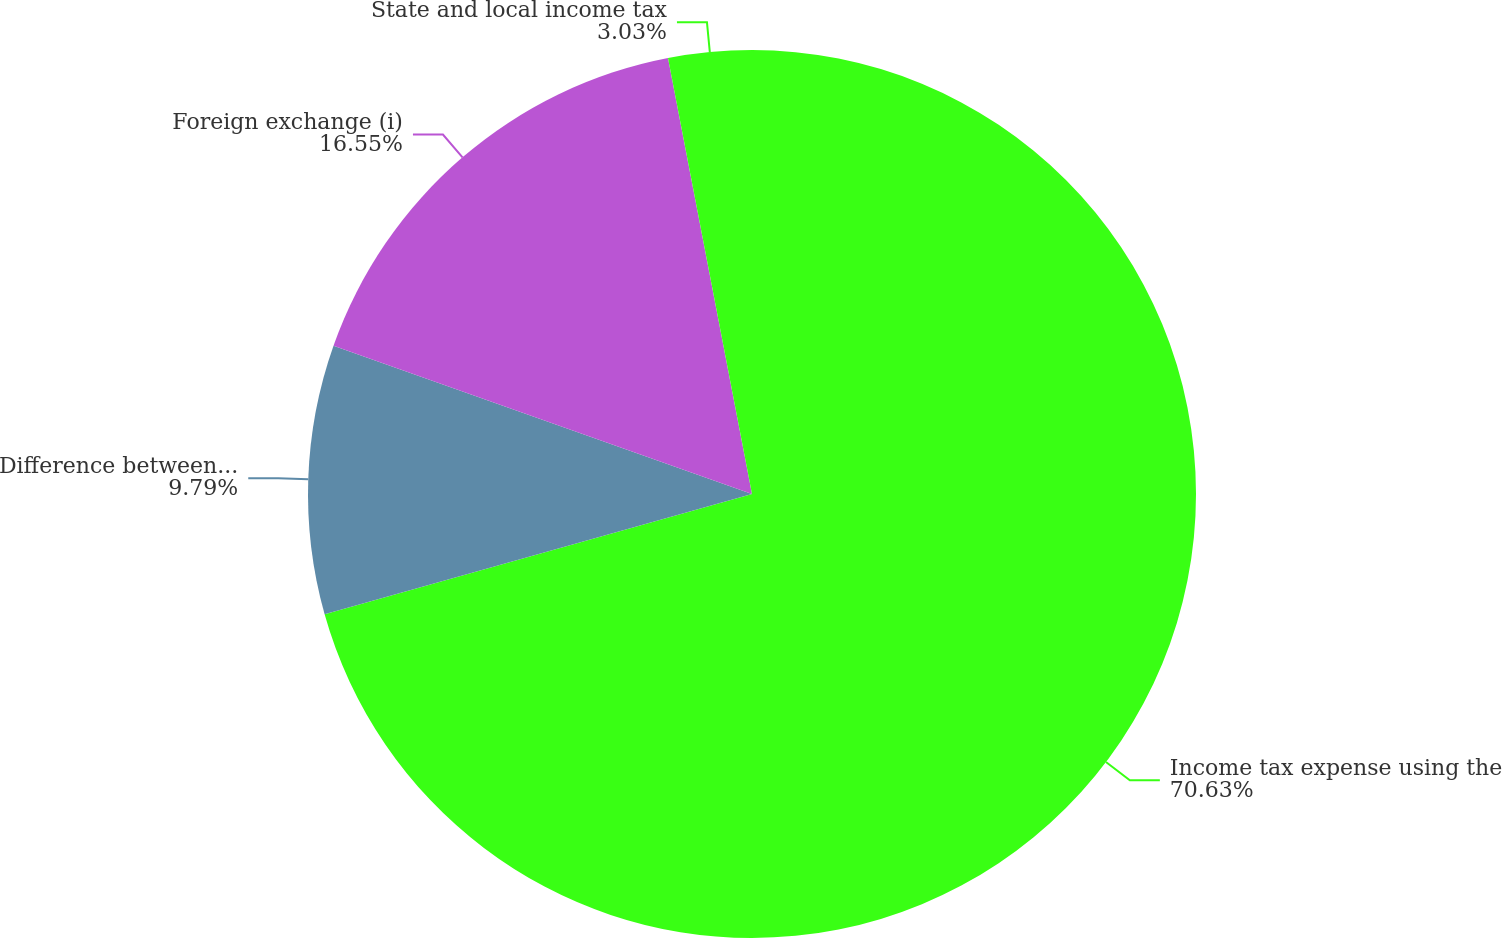Convert chart to OTSL. <chart><loc_0><loc_0><loc_500><loc_500><pie_chart><fcel>Income tax expense using the<fcel>Difference between US and<fcel>Foreign exchange (i)<fcel>State and local income tax<nl><fcel>70.64%<fcel>9.79%<fcel>16.55%<fcel>3.03%<nl></chart> 